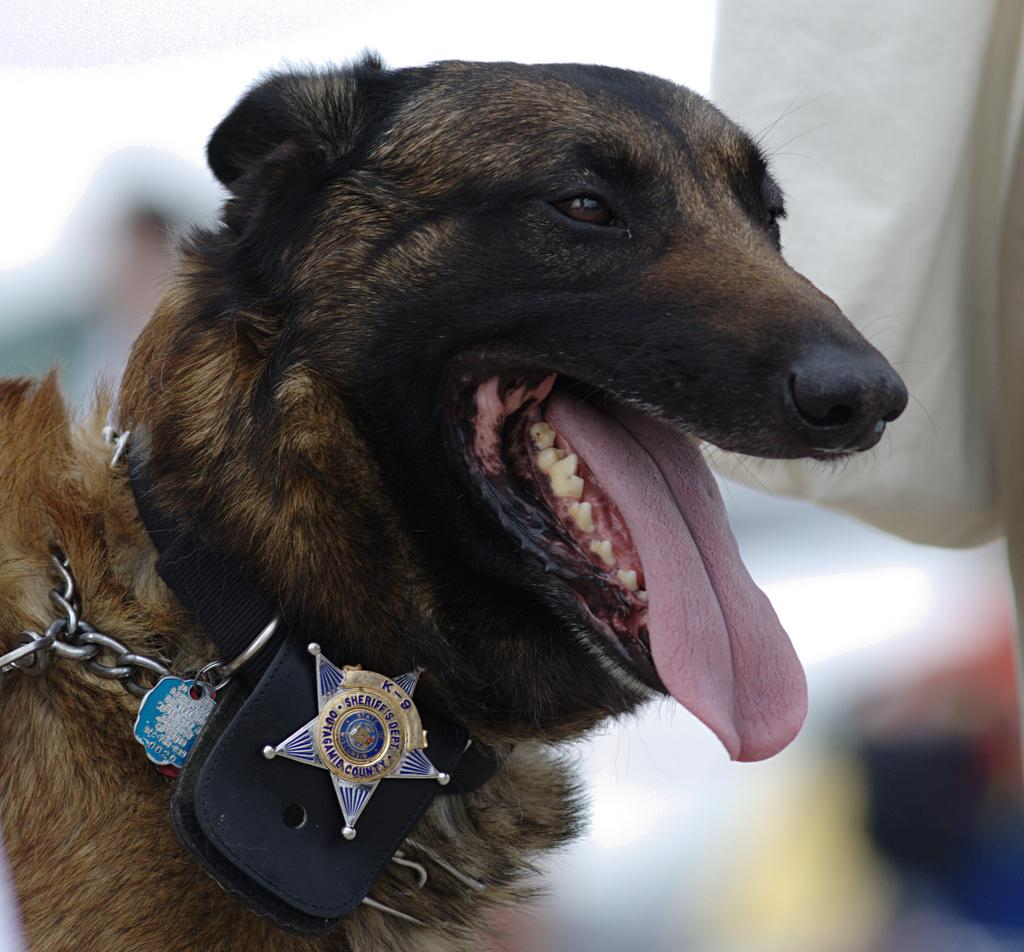What animal can be seen in the image? There is a dog in the image. Where is the dog positioned in the image? The dog is in the front. What is the dog wearing in the image? The dog is wearing a black belt. What is attached to the belt? There is a batch on the belt. What type of stocking is the dog wearing on its legs in the image? There is no stocking visible on the dog's legs in the image. What kind of building can be seen in the background of the image? There is no building present in the image; it only features the dog and the belt with a batch. 